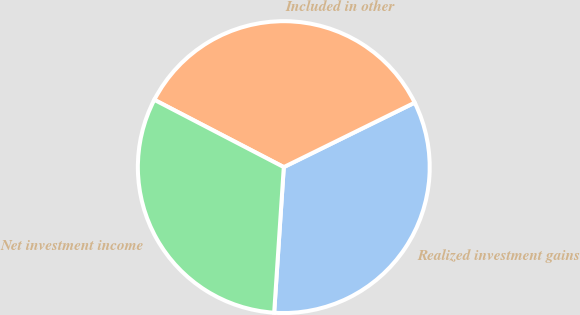Convert chart to OTSL. <chart><loc_0><loc_0><loc_500><loc_500><pie_chart><fcel>Realized investment gains<fcel>Included in other<fcel>Net investment income<nl><fcel>33.33%<fcel>35.09%<fcel>31.58%<nl></chart> 